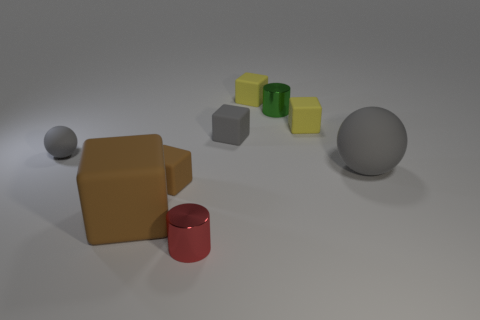How many yellow cubes must be subtracted to get 1 yellow cubes? 1 Subtract all large brown rubber cubes. How many cubes are left? 4 Subtract all brown blocks. How many blocks are left? 3 Subtract all red cubes. How many red cylinders are left? 1 Subtract all cylinders. How many objects are left? 7 Subtract 2 balls. How many balls are left? 0 Subtract all green cylinders. Subtract all red spheres. How many cylinders are left? 1 Subtract all metallic cylinders. Subtract all big brown matte cubes. How many objects are left? 6 Add 1 small red cylinders. How many small red cylinders are left? 2 Add 9 tiny spheres. How many tiny spheres exist? 10 